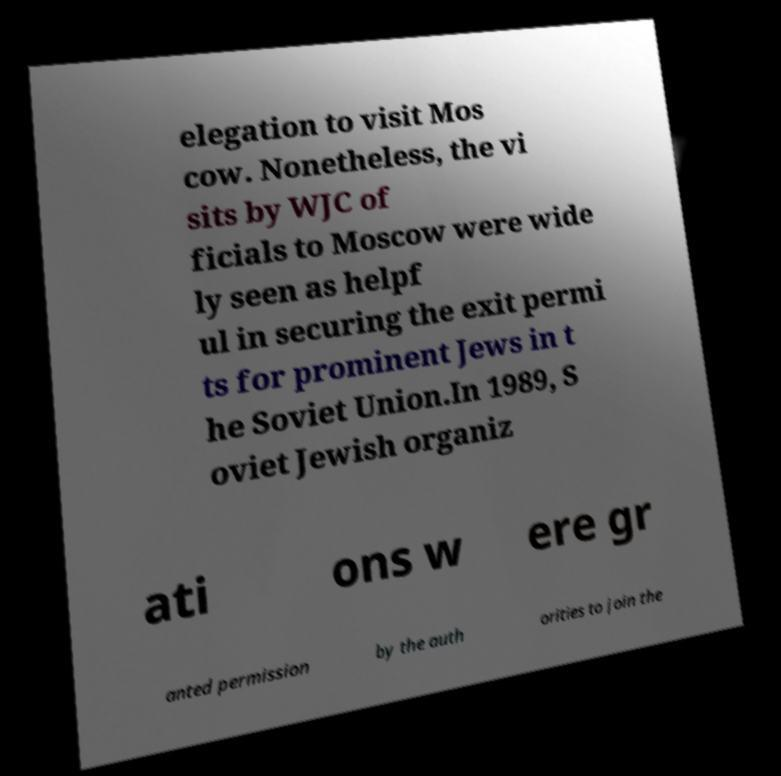For documentation purposes, I need the text within this image transcribed. Could you provide that? elegation to visit Mos cow. Nonetheless, the vi sits by WJC of ficials to Moscow were wide ly seen as helpf ul in securing the exit permi ts for prominent Jews in t he Soviet Union.In 1989, S oviet Jewish organiz ati ons w ere gr anted permission by the auth orities to join the 